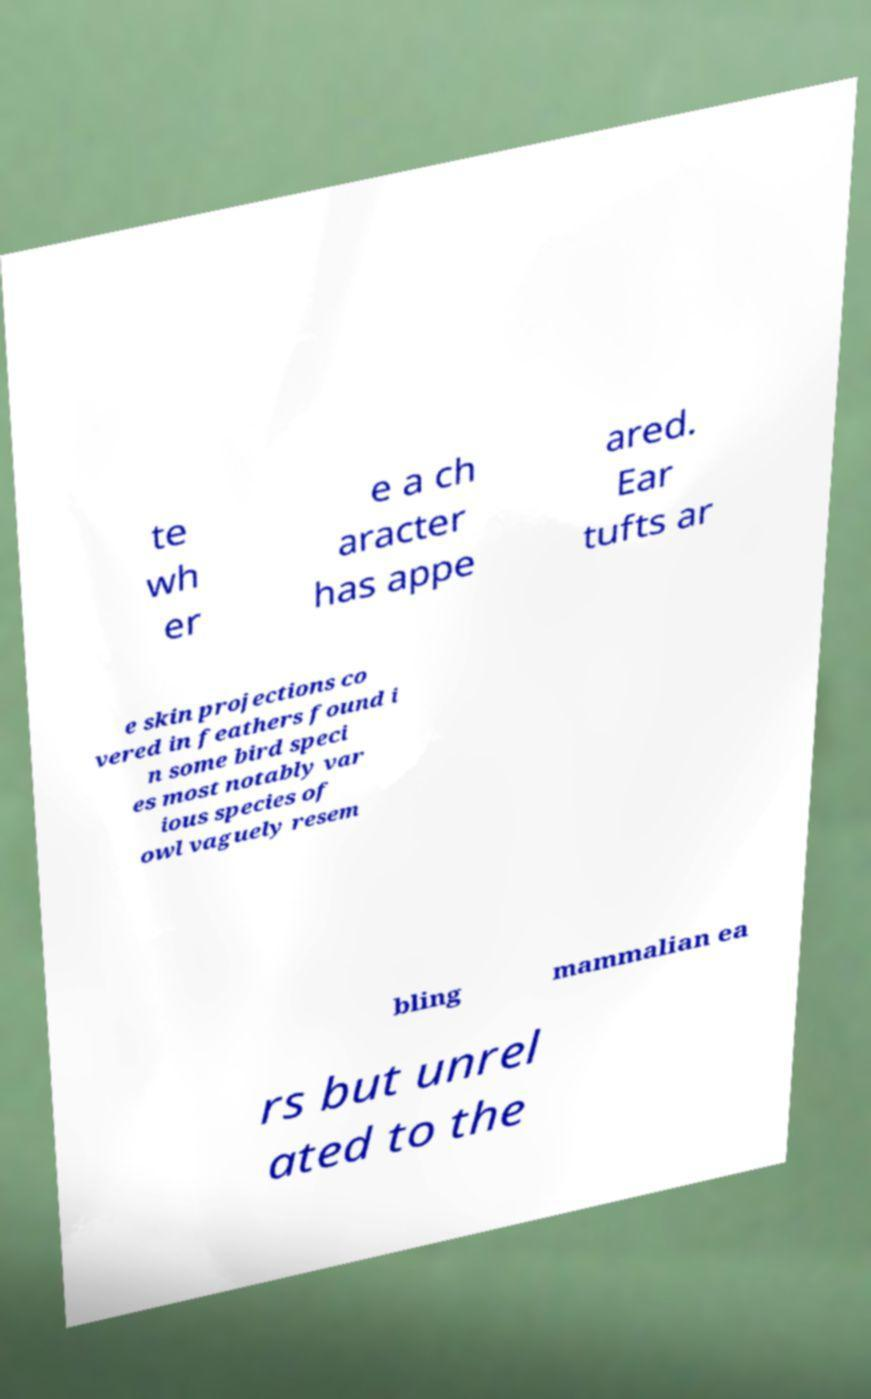Please identify and transcribe the text found in this image. te wh er e a ch aracter has appe ared. Ear tufts ar e skin projections co vered in feathers found i n some bird speci es most notably var ious species of owl vaguely resem bling mammalian ea rs but unrel ated to the 